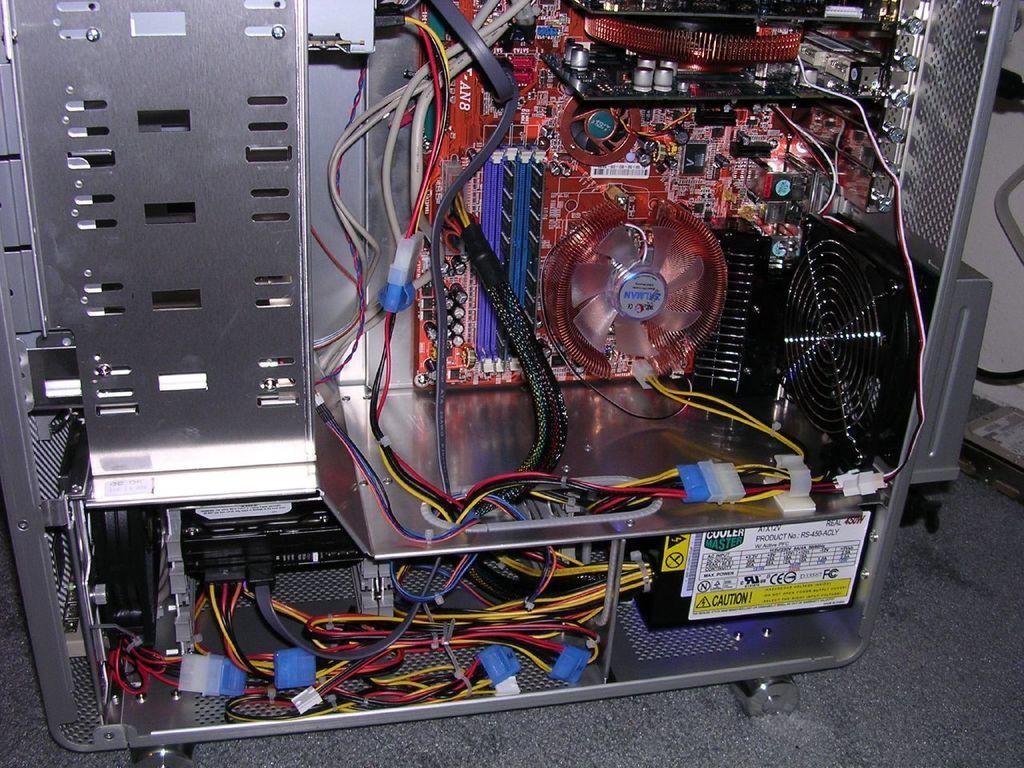Describe this image in one or two sentences. In the image we can see inside view of CPU. Behind the CPU there is wall. 